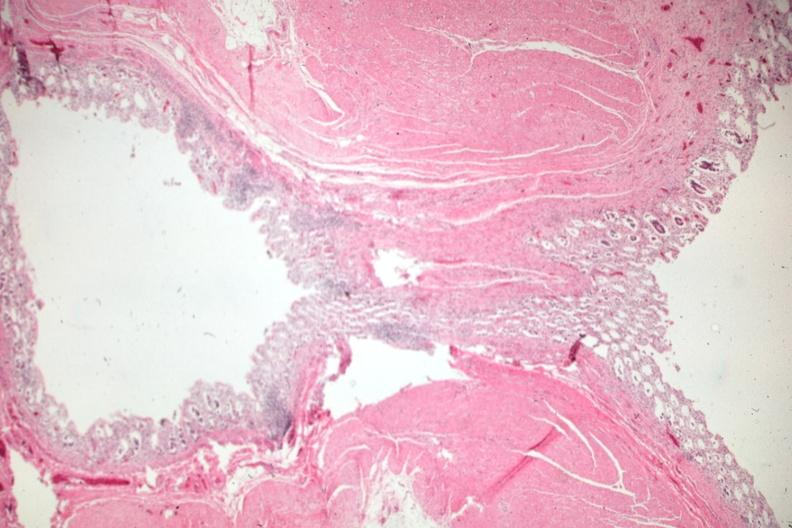what does this image show?
Answer the question using a single word or phrase. Exceptional view of an uncomplicated diverticulum 